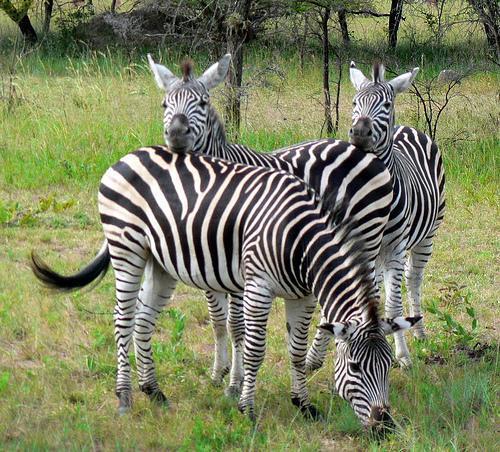How many zebra are in this photo?
Give a very brief answer. 3. How many legs are there?
Give a very brief answer. 12. How many zebras are in the picture?
Give a very brief answer. 3. 